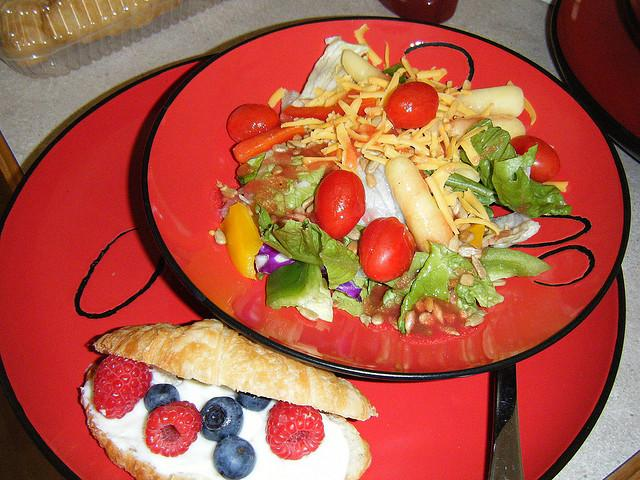How many items qualify as a berry botanically?

Choices:
A) two
B) three
C) one
D) four two 